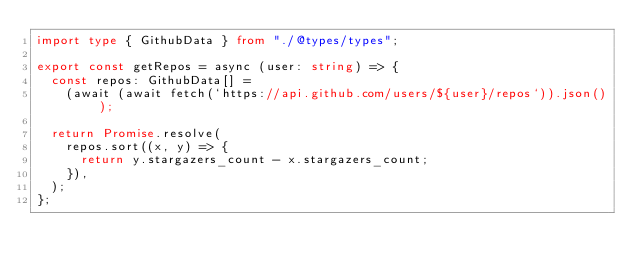Convert code to text. <code><loc_0><loc_0><loc_500><loc_500><_TypeScript_>import type { GithubData } from "./@types/types";

export const getRepos = async (user: string) => {
  const repos: GithubData[] =
    (await (await fetch(`https://api.github.com/users/${user}/repos`)).json());

  return Promise.resolve(
    repos.sort((x, y) => {
      return y.stargazers_count - x.stargazers_count;
    }),
  );
};
</code> 